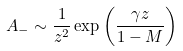<formula> <loc_0><loc_0><loc_500><loc_500>A _ { - } \sim \frac { 1 } { z ^ { 2 } } \exp \left ( \frac { \gamma z } { 1 - M } \right )</formula> 